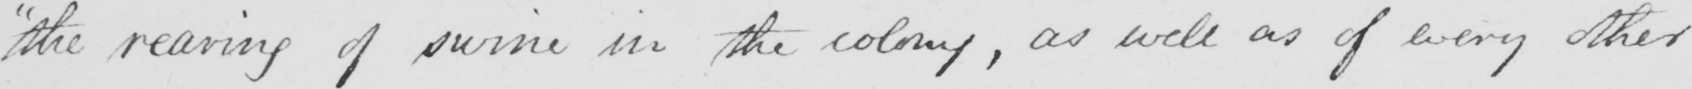What is written in this line of handwriting? "the rearing of swine in the colony, as well as of every other 